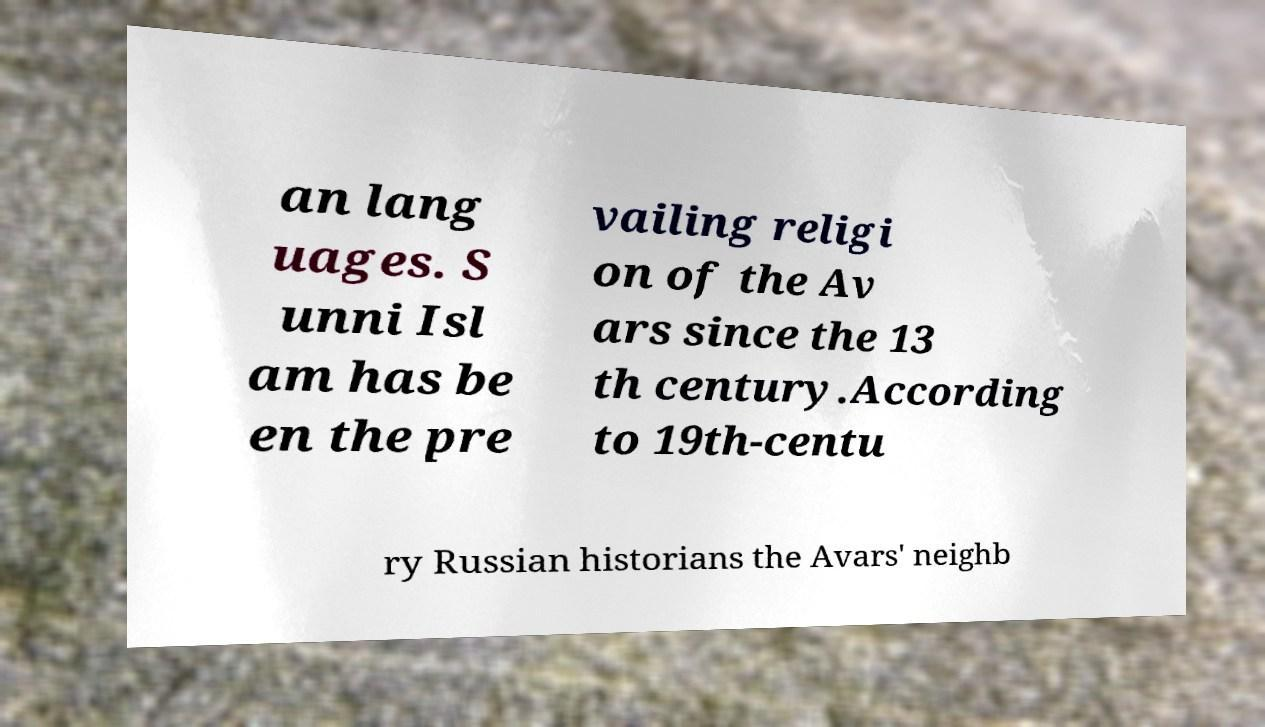I need the written content from this picture converted into text. Can you do that? an lang uages. S unni Isl am has be en the pre vailing religi on of the Av ars since the 13 th century.According to 19th-centu ry Russian historians the Avars' neighb 